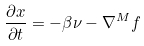Convert formula to latex. <formula><loc_0><loc_0><loc_500><loc_500>\frac { \partial x } { \partial t } = - \beta \nu - \nabla ^ { M } f</formula> 